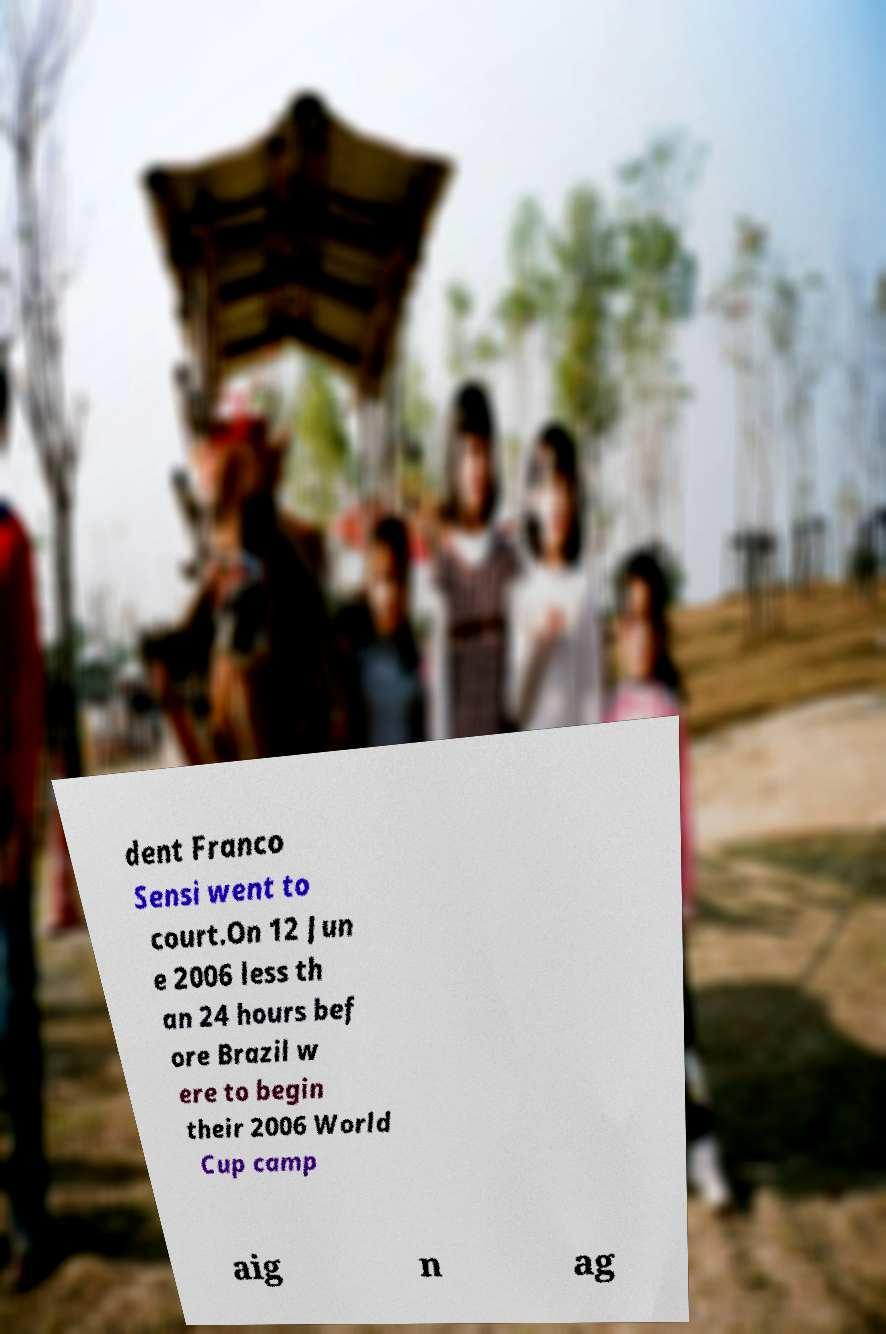Could you extract and type out the text from this image? dent Franco Sensi went to court.On 12 Jun e 2006 less th an 24 hours bef ore Brazil w ere to begin their 2006 World Cup camp aig n ag 